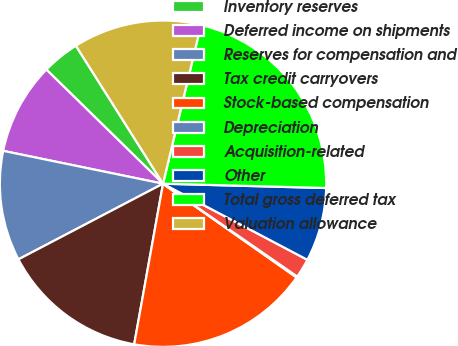Convert chart to OTSL. <chart><loc_0><loc_0><loc_500><loc_500><pie_chart><fcel>Inventory reserves<fcel>Deferred income on shipments<fcel>Reserves for compensation and<fcel>Tax credit carryovers<fcel>Stock-based compensation<fcel>Depreciation<fcel>Acquisition-related<fcel>Other<fcel>Total gross deferred tax<fcel>Valuation allowance<nl><fcel>3.71%<fcel>9.1%<fcel>10.9%<fcel>14.5%<fcel>18.09%<fcel>0.11%<fcel>1.91%<fcel>7.3%<fcel>21.69%<fcel>12.7%<nl></chart> 